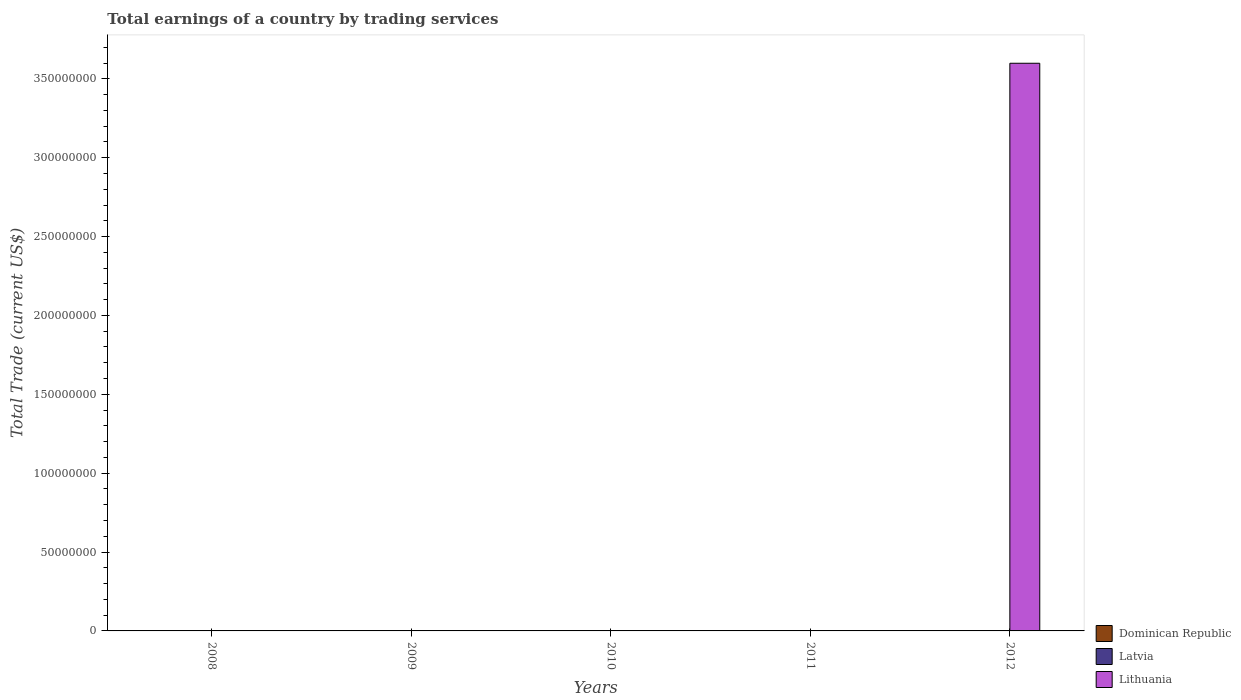How many different coloured bars are there?
Offer a very short reply. 1. Are the number of bars per tick equal to the number of legend labels?
Ensure brevity in your answer.  No. Are the number of bars on each tick of the X-axis equal?
Ensure brevity in your answer.  No. What is the total earnings in Lithuania in 2012?
Make the answer very short. 3.60e+08. Across all years, what is the maximum total earnings in Lithuania?
Your answer should be very brief. 3.60e+08. Across all years, what is the minimum total earnings in Latvia?
Your response must be concise. 0. In which year was the total earnings in Lithuania maximum?
Offer a very short reply. 2012. What is the total total earnings in Lithuania in the graph?
Provide a succinct answer. 3.60e+08. What is the difference between the highest and the lowest total earnings in Lithuania?
Your response must be concise. 3.60e+08. In how many years, is the total earnings in Dominican Republic greater than the average total earnings in Dominican Republic taken over all years?
Your response must be concise. 0. How many bars are there?
Ensure brevity in your answer.  1. How many years are there in the graph?
Keep it short and to the point. 5. What is the difference between two consecutive major ticks on the Y-axis?
Your answer should be very brief. 5.00e+07. Where does the legend appear in the graph?
Ensure brevity in your answer.  Bottom right. How many legend labels are there?
Your answer should be very brief. 3. How are the legend labels stacked?
Provide a short and direct response. Vertical. What is the title of the graph?
Offer a terse response. Total earnings of a country by trading services. Does "Gabon" appear as one of the legend labels in the graph?
Offer a terse response. No. What is the label or title of the Y-axis?
Your answer should be very brief. Total Trade (current US$). What is the Total Trade (current US$) in Dominican Republic in 2008?
Your answer should be very brief. 0. What is the Total Trade (current US$) in Lithuania in 2009?
Provide a succinct answer. 0. What is the Total Trade (current US$) of Dominican Republic in 2010?
Your answer should be compact. 0. What is the Total Trade (current US$) of Dominican Republic in 2011?
Offer a terse response. 0. What is the Total Trade (current US$) of Latvia in 2012?
Your answer should be compact. 0. What is the Total Trade (current US$) in Lithuania in 2012?
Provide a short and direct response. 3.60e+08. Across all years, what is the maximum Total Trade (current US$) of Lithuania?
Your answer should be very brief. 3.60e+08. What is the total Total Trade (current US$) in Lithuania in the graph?
Keep it short and to the point. 3.60e+08. What is the average Total Trade (current US$) of Dominican Republic per year?
Your response must be concise. 0. What is the average Total Trade (current US$) in Latvia per year?
Your answer should be very brief. 0. What is the average Total Trade (current US$) of Lithuania per year?
Keep it short and to the point. 7.20e+07. What is the difference between the highest and the lowest Total Trade (current US$) of Lithuania?
Your response must be concise. 3.60e+08. 